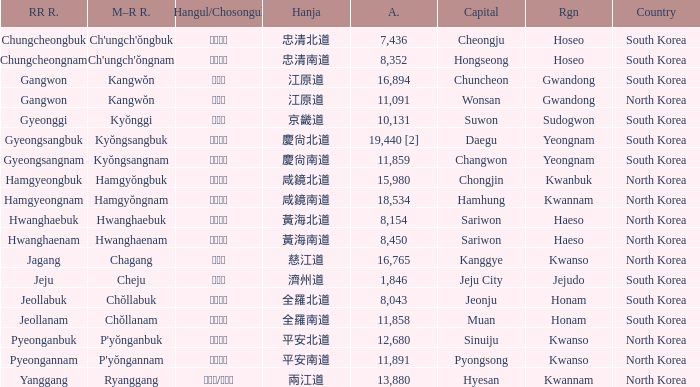Which capital has a Hangul of 경상남도? Changwon. 